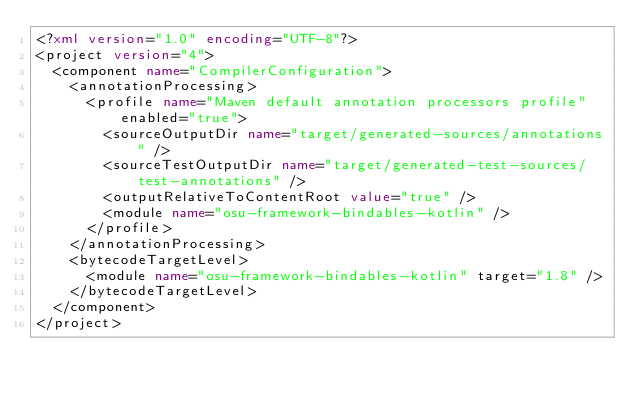Convert code to text. <code><loc_0><loc_0><loc_500><loc_500><_XML_><?xml version="1.0" encoding="UTF-8"?>
<project version="4">
  <component name="CompilerConfiguration">
    <annotationProcessing>
      <profile name="Maven default annotation processors profile" enabled="true">
        <sourceOutputDir name="target/generated-sources/annotations" />
        <sourceTestOutputDir name="target/generated-test-sources/test-annotations" />
        <outputRelativeToContentRoot value="true" />
        <module name="osu-framework-bindables-kotlin" />
      </profile>
    </annotationProcessing>
    <bytecodeTargetLevel>
      <module name="osu-framework-bindables-kotlin" target="1.8" />
    </bytecodeTargetLevel>
  </component>
</project></code> 